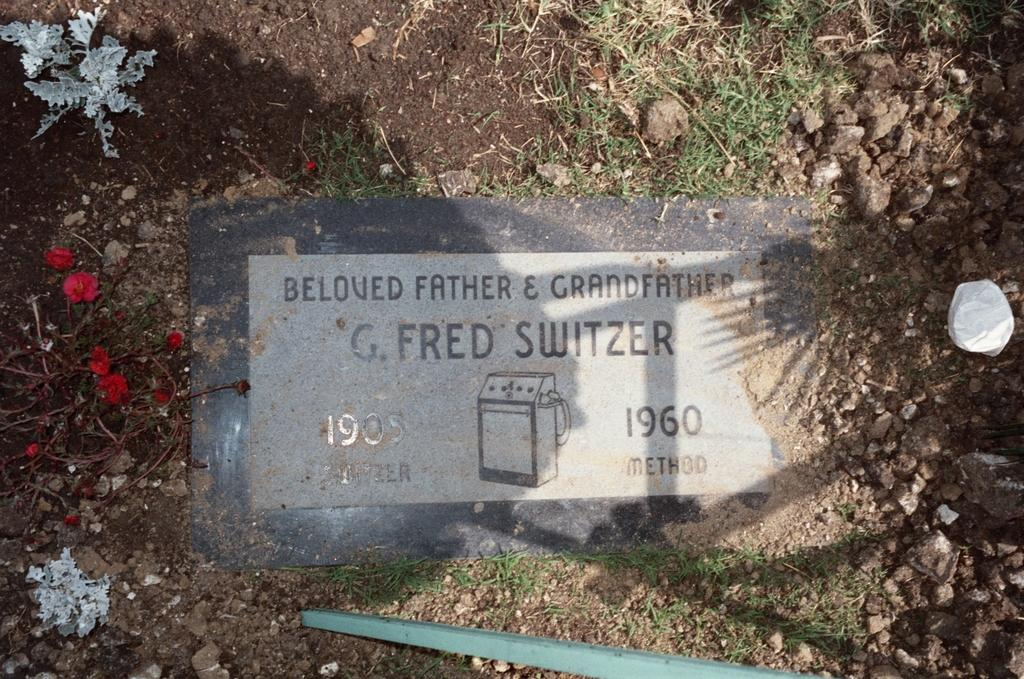What is on the ground in the image? There is a board on the ground in the image. What type of flowers are near the board? There are red color flowers near the board. Where are the flowers located? The flowers are on a plant. What type of vegetation is visible in the image? There is grass visible in the image. What other objects can be seen in the image? There are stones and a pole in the image. What type of mint is growing near the partner in the image? There is no mint or partner present in the image. 